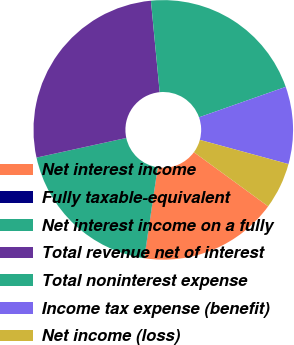<chart> <loc_0><loc_0><loc_500><loc_500><pie_chart><fcel>Net interest income<fcel>Fully taxable-equivalent<fcel>Net interest income on a fully<fcel>Total revenue net of interest<fcel>Total noninterest expense<fcel>Income tax expense (benefit)<fcel>Net income (loss)<nl><fcel>17.3%<fcel>0.02%<fcel>19.22%<fcel>26.9%<fcel>21.14%<fcel>9.62%<fcel>5.78%<nl></chart> 